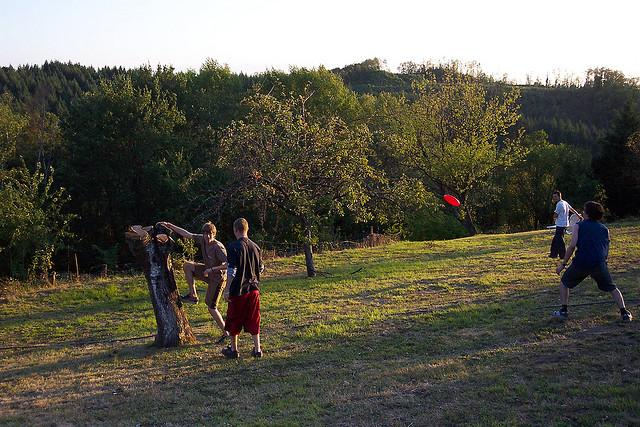Why does the boy have his leg on the tree? to climb 